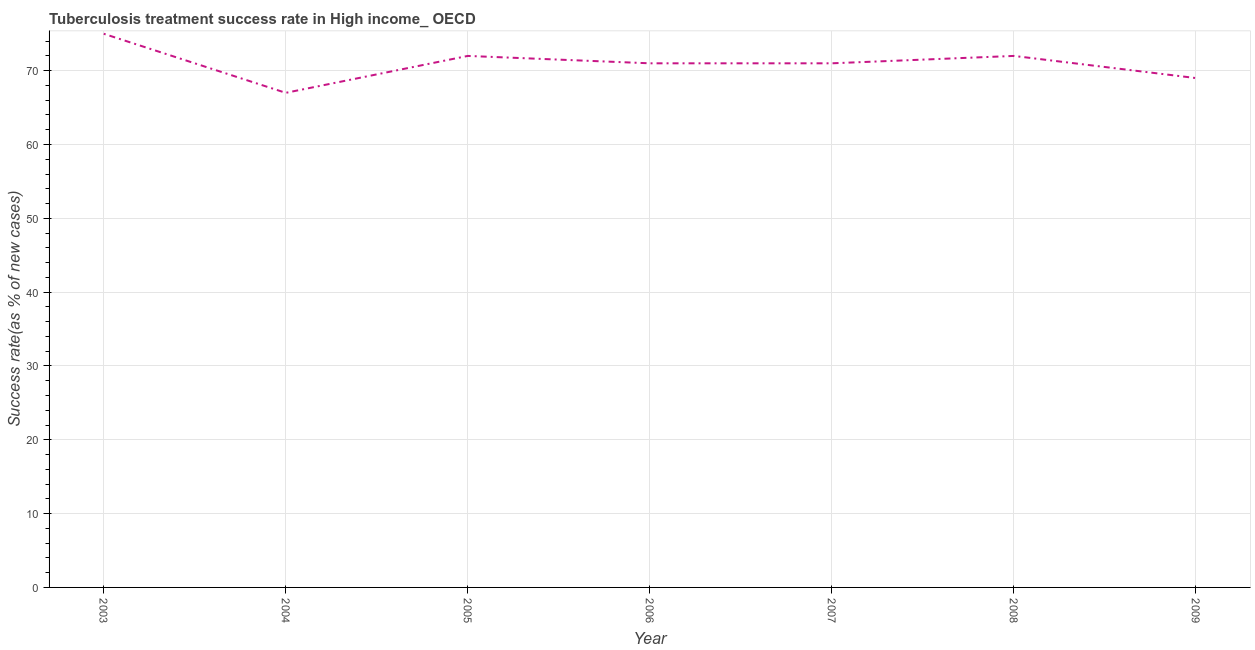What is the tuberculosis treatment success rate in 2005?
Give a very brief answer. 72. Across all years, what is the maximum tuberculosis treatment success rate?
Provide a short and direct response. 75. Across all years, what is the minimum tuberculosis treatment success rate?
Your answer should be compact. 67. What is the sum of the tuberculosis treatment success rate?
Offer a very short reply. 497. What is the difference between the tuberculosis treatment success rate in 2003 and 2004?
Your answer should be compact. 8. What is the median tuberculosis treatment success rate?
Offer a very short reply. 71. In how many years, is the tuberculosis treatment success rate greater than 16 %?
Offer a terse response. 7. Do a majority of the years between 2009 and 2005 (inclusive) have tuberculosis treatment success rate greater than 42 %?
Your answer should be compact. Yes. What is the ratio of the tuberculosis treatment success rate in 2004 to that in 2005?
Your answer should be very brief. 0.93. Is the tuberculosis treatment success rate in 2005 less than that in 2008?
Give a very brief answer. No. What is the difference between the highest and the second highest tuberculosis treatment success rate?
Your response must be concise. 3. What is the difference between the highest and the lowest tuberculosis treatment success rate?
Give a very brief answer. 8. Does the tuberculosis treatment success rate monotonically increase over the years?
Offer a terse response. No. How many years are there in the graph?
Your answer should be compact. 7. What is the difference between two consecutive major ticks on the Y-axis?
Offer a very short reply. 10. Are the values on the major ticks of Y-axis written in scientific E-notation?
Provide a succinct answer. No. Does the graph contain any zero values?
Make the answer very short. No. What is the title of the graph?
Provide a short and direct response. Tuberculosis treatment success rate in High income_ OECD. What is the label or title of the X-axis?
Make the answer very short. Year. What is the label or title of the Y-axis?
Ensure brevity in your answer.  Success rate(as % of new cases). What is the Success rate(as % of new cases) in 2003?
Give a very brief answer. 75. What is the Success rate(as % of new cases) of 2008?
Your response must be concise. 72. What is the Success rate(as % of new cases) of 2009?
Your answer should be compact. 69. What is the difference between the Success rate(as % of new cases) in 2003 and 2004?
Ensure brevity in your answer.  8. What is the difference between the Success rate(as % of new cases) in 2003 and 2005?
Provide a short and direct response. 3. What is the difference between the Success rate(as % of new cases) in 2003 and 2007?
Offer a very short reply. 4. What is the difference between the Success rate(as % of new cases) in 2004 and 2005?
Your answer should be very brief. -5. What is the difference between the Success rate(as % of new cases) in 2004 and 2007?
Offer a very short reply. -4. What is the difference between the Success rate(as % of new cases) in 2004 and 2008?
Provide a succinct answer. -5. What is the difference between the Success rate(as % of new cases) in 2005 and 2006?
Keep it short and to the point. 1. What is the difference between the Success rate(as % of new cases) in 2005 and 2007?
Your answer should be compact. 1. What is the difference between the Success rate(as % of new cases) in 2005 and 2009?
Keep it short and to the point. 3. What is the difference between the Success rate(as % of new cases) in 2006 and 2007?
Ensure brevity in your answer.  0. What is the difference between the Success rate(as % of new cases) in 2007 and 2009?
Give a very brief answer. 2. What is the difference between the Success rate(as % of new cases) in 2008 and 2009?
Offer a terse response. 3. What is the ratio of the Success rate(as % of new cases) in 2003 to that in 2004?
Ensure brevity in your answer.  1.12. What is the ratio of the Success rate(as % of new cases) in 2003 to that in 2005?
Ensure brevity in your answer.  1.04. What is the ratio of the Success rate(as % of new cases) in 2003 to that in 2006?
Provide a succinct answer. 1.06. What is the ratio of the Success rate(as % of new cases) in 2003 to that in 2007?
Your answer should be very brief. 1.06. What is the ratio of the Success rate(as % of new cases) in 2003 to that in 2008?
Your answer should be compact. 1.04. What is the ratio of the Success rate(as % of new cases) in 2003 to that in 2009?
Your answer should be very brief. 1.09. What is the ratio of the Success rate(as % of new cases) in 2004 to that in 2006?
Your answer should be compact. 0.94. What is the ratio of the Success rate(as % of new cases) in 2004 to that in 2007?
Give a very brief answer. 0.94. What is the ratio of the Success rate(as % of new cases) in 2004 to that in 2009?
Make the answer very short. 0.97. What is the ratio of the Success rate(as % of new cases) in 2005 to that in 2007?
Your answer should be compact. 1.01. What is the ratio of the Success rate(as % of new cases) in 2005 to that in 2009?
Provide a short and direct response. 1.04. What is the ratio of the Success rate(as % of new cases) in 2006 to that in 2007?
Your answer should be very brief. 1. What is the ratio of the Success rate(as % of new cases) in 2006 to that in 2008?
Offer a very short reply. 0.99. What is the ratio of the Success rate(as % of new cases) in 2007 to that in 2008?
Ensure brevity in your answer.  0.99. What is the ratio of the Success rate(as % of new cases) in 2007 to that in 2009?
Make the answer very short. 1.03. What is the ratio of the Success rate(as % of new cases) in 2008 to that in 2009?
Provide a succinct answer. 1.04. 